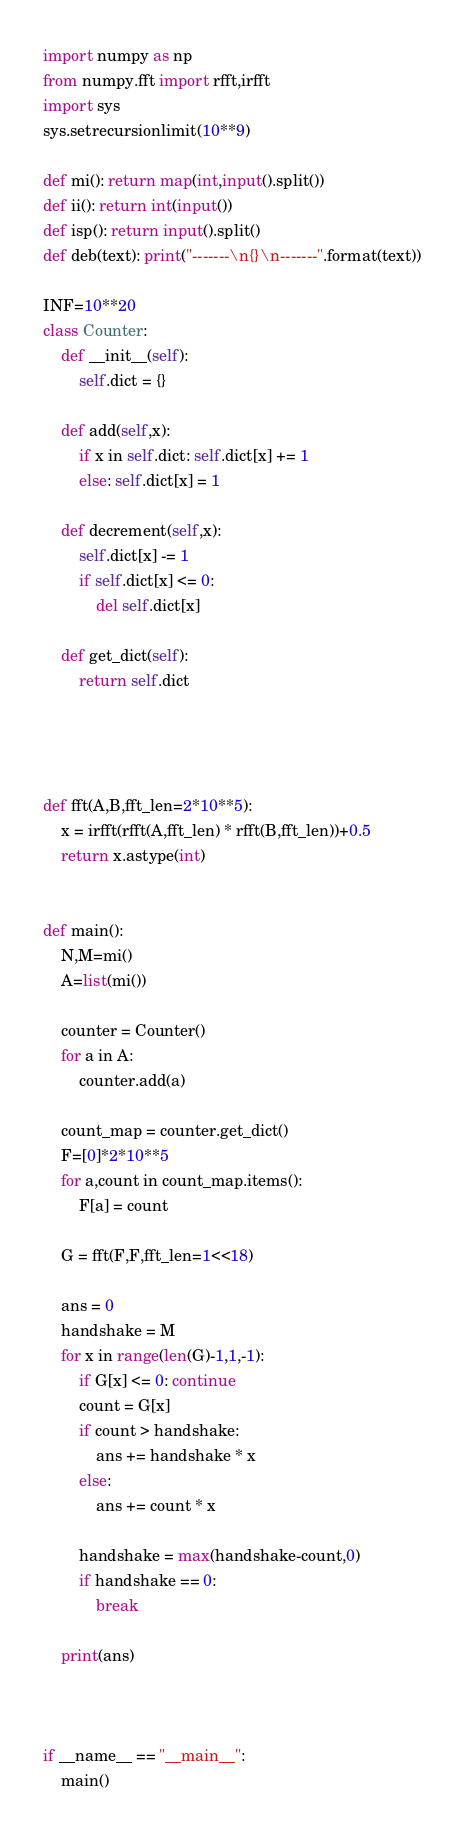<code> <loc_0><loc_0><loc_500><loc_500><_Python_>import numpy as np
from numpy.fft import rfft,irfft
import sys
sys.setrecursionlimit(10**9)

def mi(): return map(int,input().split())
def ii(): return int(input())
def isp(): return input().split()
def deb(text): print("-------\n{}\n-------".format(text))

INF=10**20
class Counter:
    def __init__(self):
        self.dict = {}

    def add(self,x):
        if x in self.dict: self.dict[x] += 1
        else: self.dict[x] = 1

    def decrement(self,x):
        self.dict[x] -= 1
        if self.dict[x] <= 0:
            del self.dict[x]

    def get_dict(self):
        return self.dict




def fft(A,B,fft_len=2*10**5):
    x = irfft(rfft(A,fft_len) * rfft(B,fft_len))+0.5
    return x.astype(int)


def main():
    N,M=mi()
    A=list(mi())

    counter = Counter()
    for a in A: 
        counter.add(a)
    
    count_map = counter.get_dict()
    F=[0]*2*10**5
    for a,count in count_map.items():
        F[a] = count
    
    G = fft(F,F,fft_len=1<<18)

    ans = 0
    handshake = M
    for x in range(len(G)-1,1,-1):
        if G[x] <= 0: continue
        count = G[x]
        if count > handshake:
            ans += handshake * x
        else:
            ans += count * x

        handshake = max(handshake-count,0)
        if handshake == 0:
            break

    print(ans)



if __name__ == "__main__":
    main()</code> 